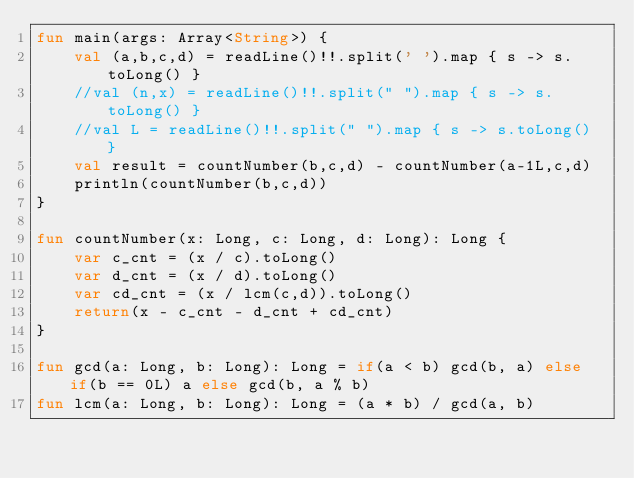Convert code to text. <code><loc_0><loc_0><loc_500><loc_500><_Kotlin_>fun main(args: Array<String>) {
    val (a,b,c,d) = readLine()!!.split(' ').map { s -> s.toLong() }
    //val (n,x) = readLine()!!.split(" ").map { s -> s.toLong() }
    //val L = readLine()!!.split(" ").map { s -> s.toLong() }
    val result = countNumber(b,c,d) - countNumber(a-1L,c,d)
    println(countNumber(b,c,d))
}

fun countNumber(x: Long, c: Long, d: Long): Long {
    var c_cnt = (x / c).toLong()
    var d_cnt = (x / d).toLong()
    var cd_cnt = (x / lcm(c,d)).toLong()
    return(x - c_cnt - d_cnt + cd_cnt)
}

fun gcd(a: Long, b: Long): Long = if(a < b) gcd(b, a) else if(b == 0L) a else gcd(b, a % b)
fun lcm(a: Long, b: Long): Long = (a * b) / gcd(a, b)</code> 